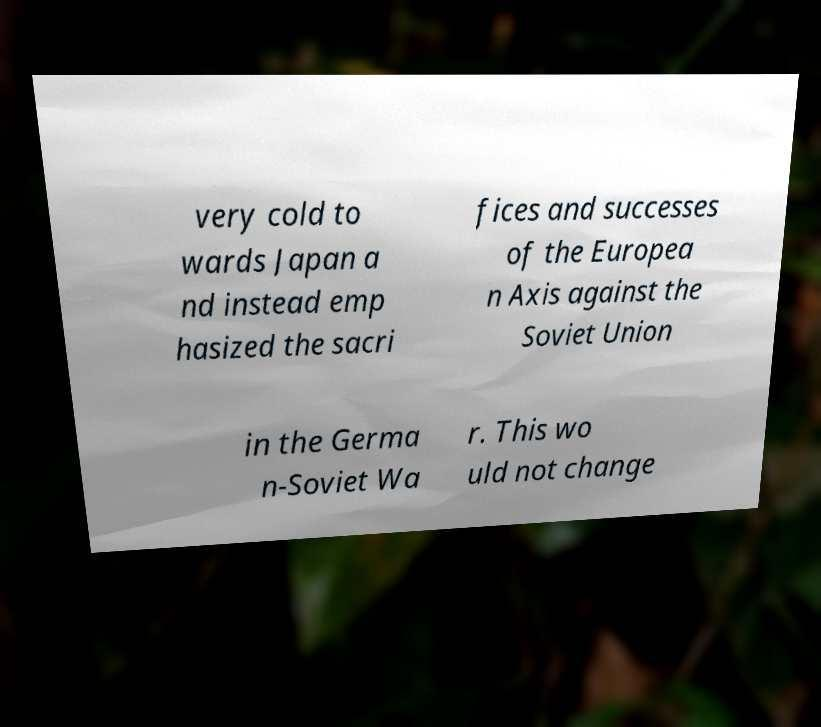For documentation purposes, I need the text within this image transcribed. Could you provide that? very cold to wards Japan a nd instead emp hasized the sacri fices and successes of the Europea n Axis against the Soviet Union in the Germa n-Soviet Wa r. This wo uld not change 